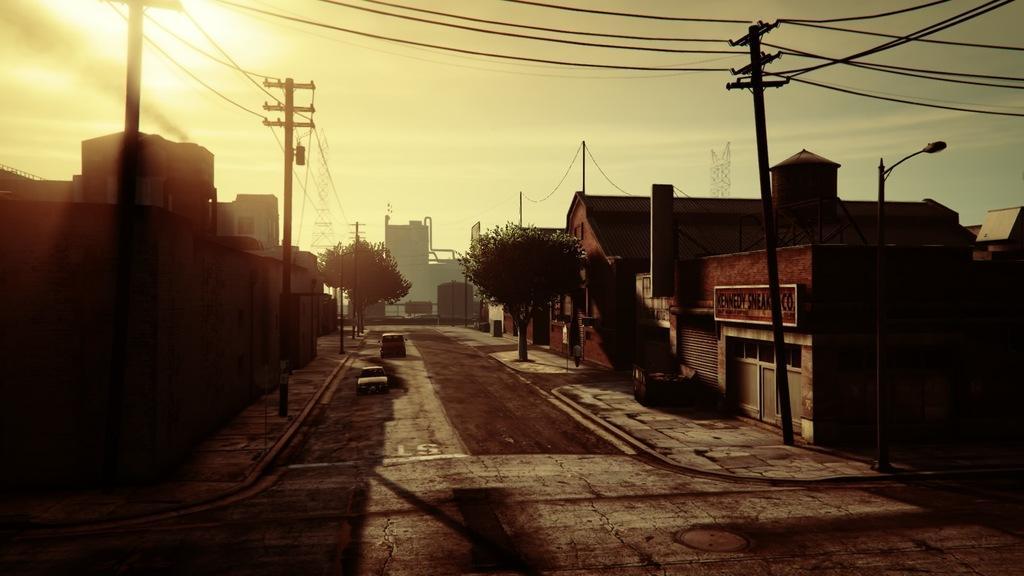Describe this image in one or two sentences. In this image few vehicles are on the road. A person is walking on the pavement having a tree. There are few poles connected with wires. Background there are few buildings. Top of image there is sky. 